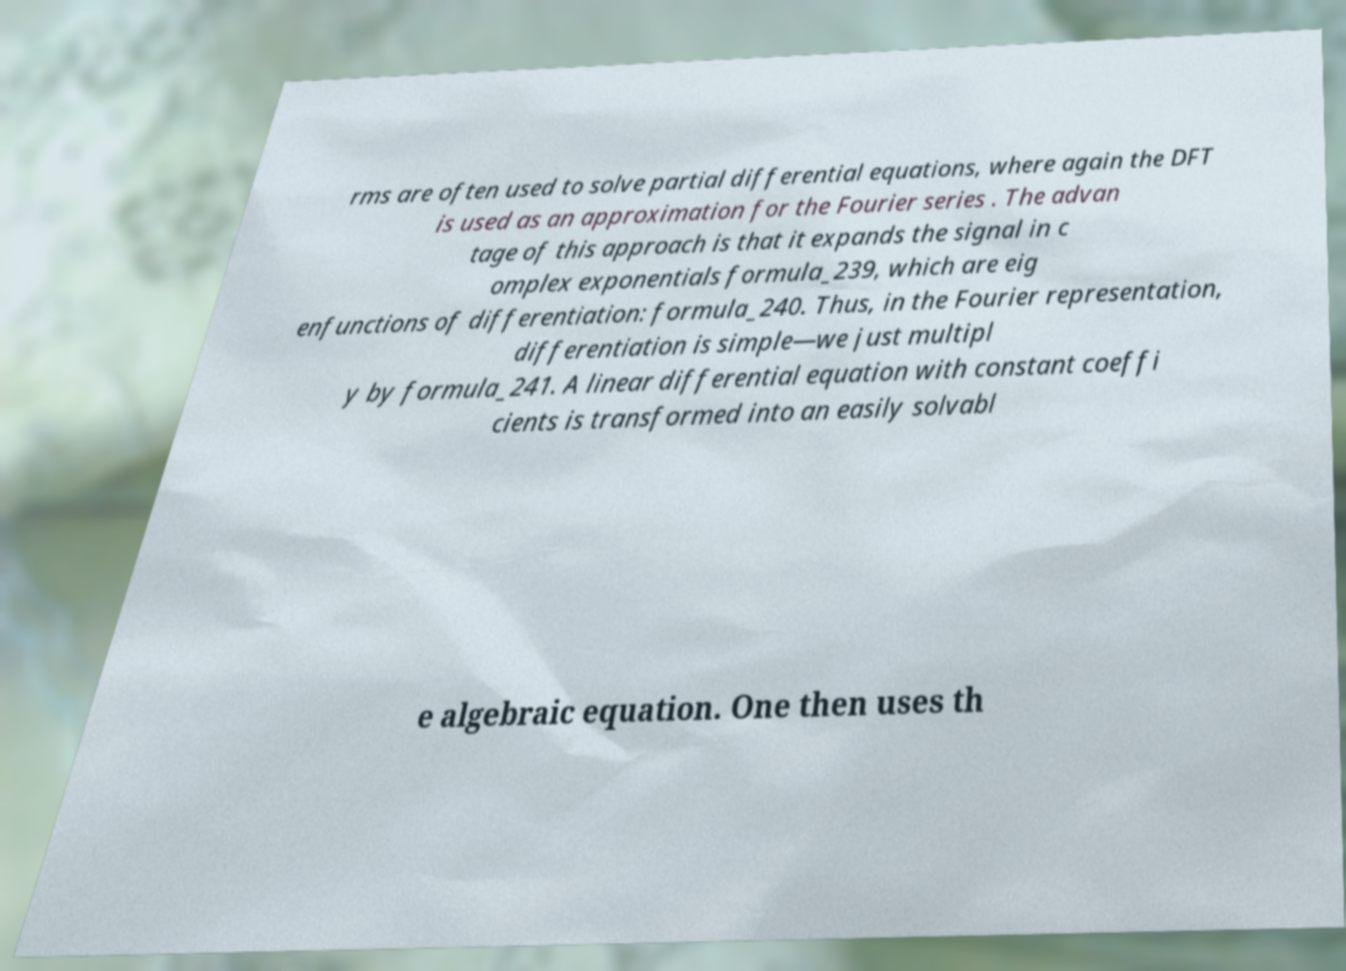Could you assist in decoding the text presented in this image and type it out clearly? rms are often used to solve partial differential equations, where again the DFT is used as an approximation for the Fourier series . The advan tage of this approach is that it expands the signal in c omplex exponentials formula_239, which are eig enfunctions of differentiation: formula_240. Thus, in the Fourier representation, differentiation is simple—we just multipl y by formula_241. A linear differential equation with constant coeffi cients is transformed into an easily solvabl e algebraic equation. One then uses th 